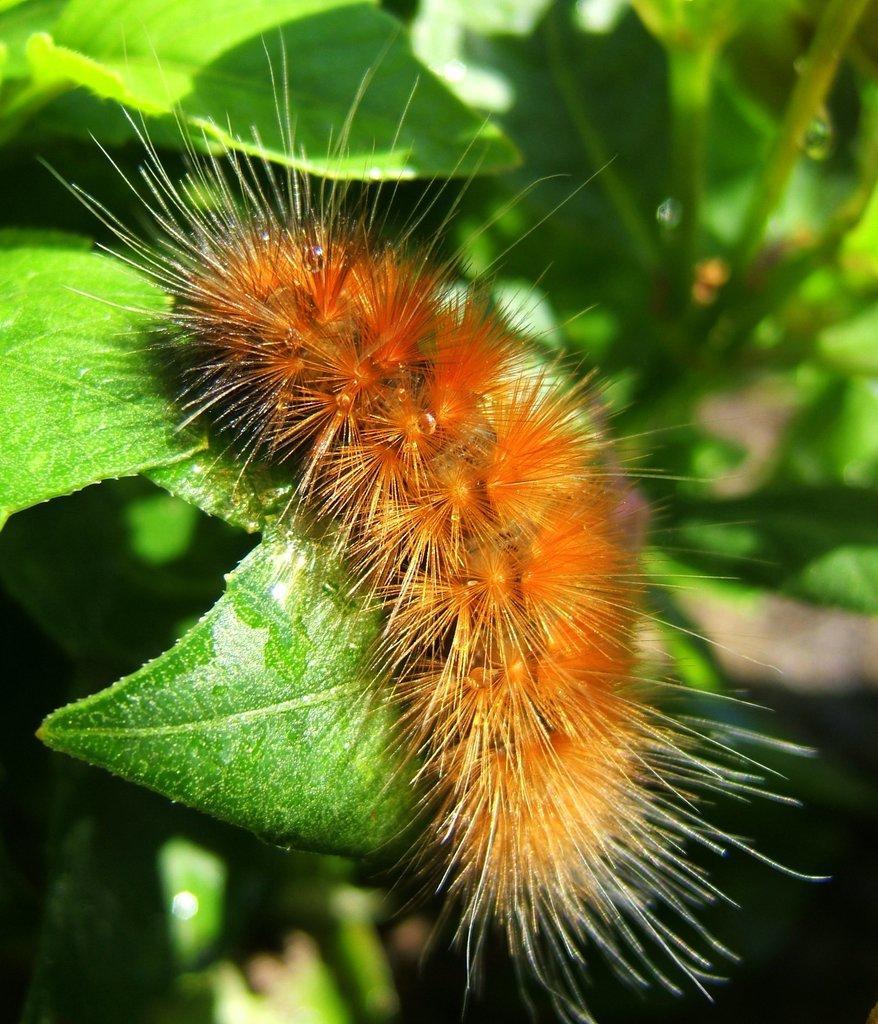In one or two sentences, can you explain what this image depicts? In the center of the image, we can see an insect and in the background, there are plants. 